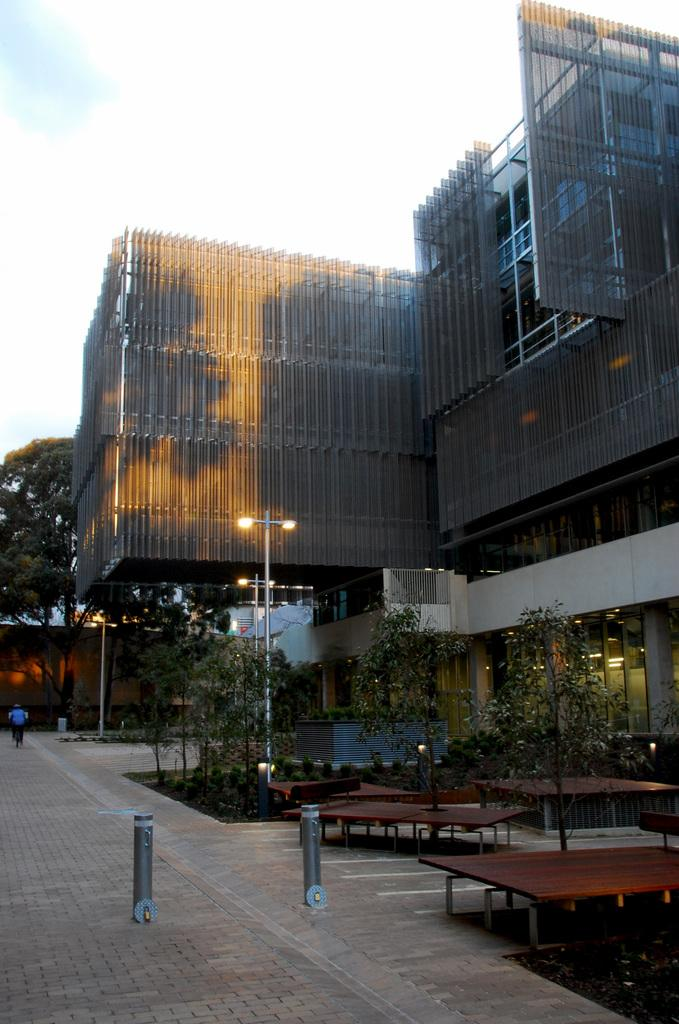What type of furniture can be seen in the image? There are tables in the image. What type of natural elements are present in the image? There are trees in the image. What type of artificial light sources are visible in the image? There are lights in the image. What type of structures are present in the image? There are poles and buildings in the image. Can you describe the person in the image? There is a person in the image. What can be seen in the background of the image? The sky is visible in the background of the image. What type of drum can be seen being played by the person in the image? There is no drum present in the image; only tables, trees, lights, poles, buildings, a person, and the sky are visible. Can you describe the fold of the person's clothing in the image? There is no specific fold of the person's clothing mentioned in the image; only the presence of a person is noted. 